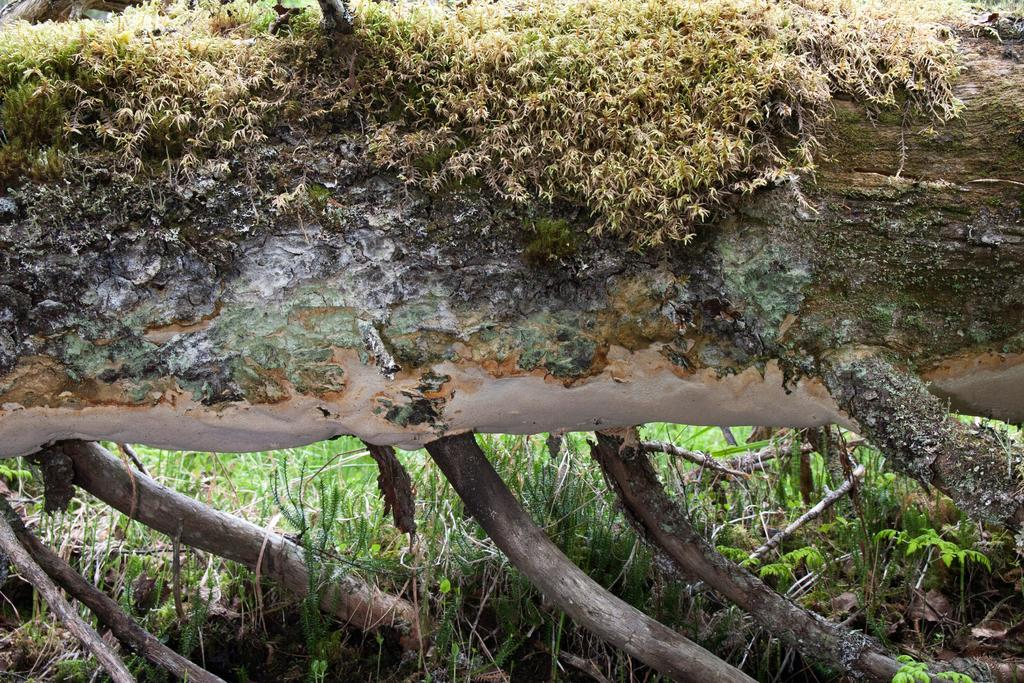What is located in the center of the image? There is a wood and grass in the center of the image. Can you describe the wood in the image? The wood appears to be a natural area with trees and vegetation. What type of vegetation is present in the center of the image? Grass is present in the center of the image. What type of bit can be seen in the image? There is no bit present in the image. Can you describe the harbor in the image? There is no harbor present in the image; it features a wood and grass. 